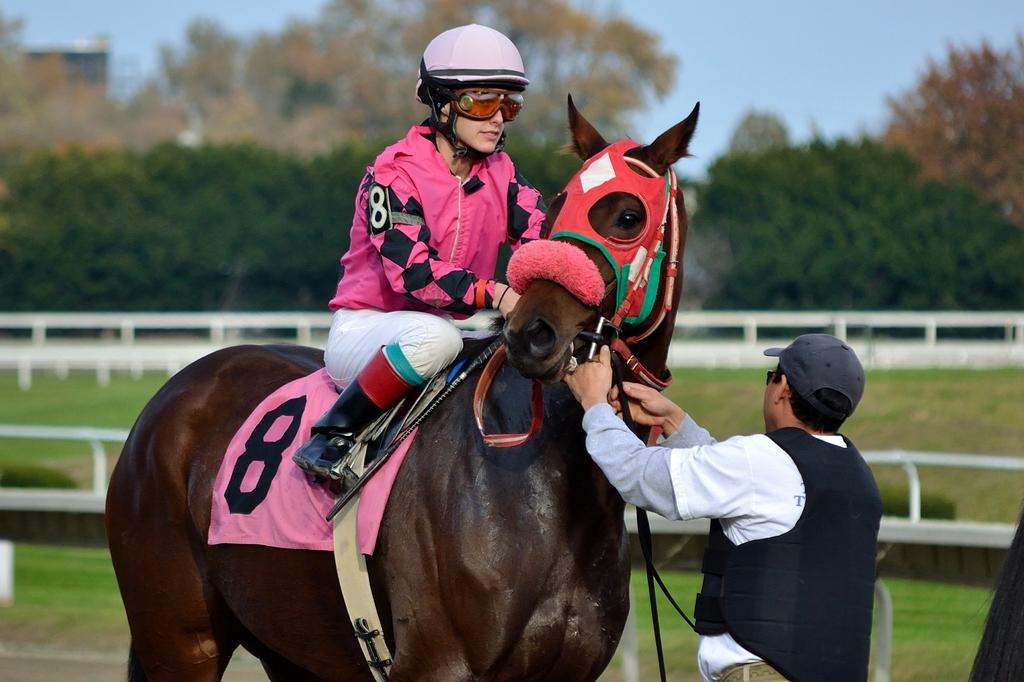What is the lady in the image doing? The lady is sitting on a horse in the image. Who else is present in the image? There is a man standing on the right side of the image. What can be seen in the background of the image? There are trees and the sky visible in the background of the image. What is the purpose of the fence in the image? The purpose of the fence in the image is not specified, but it could be used to enclose an area or mark a boundary. What type of dust can be seen on the cactus in the image? There is no cactus present in the image, and therefore no dust on it. 